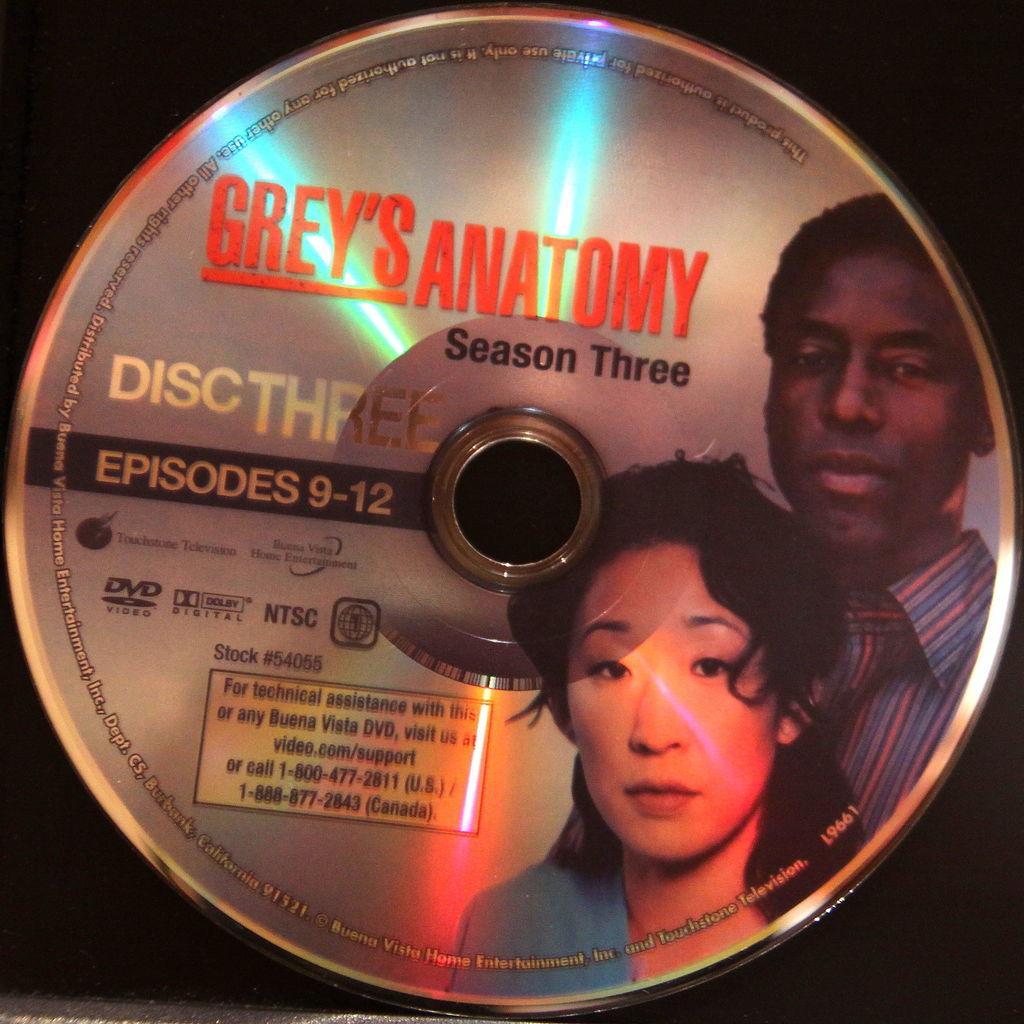How would you summarize this image in a sentence or two? In the picture we can see a disk on it, we can see an image of man and woman and some name on it as grey's anatomy. 